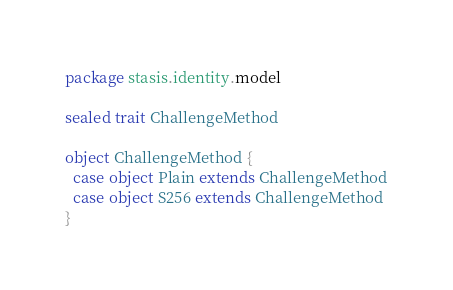<code> <loc_0><loc_0><loc_500><loc_500><_Scala_>package stasis.identity.model

sealed trait ChallengeMethod

object ChallengeMethod {
  case object Plain extends ChallengeMethod
  case object S256 extends ChallengeMethod
}
</code> 